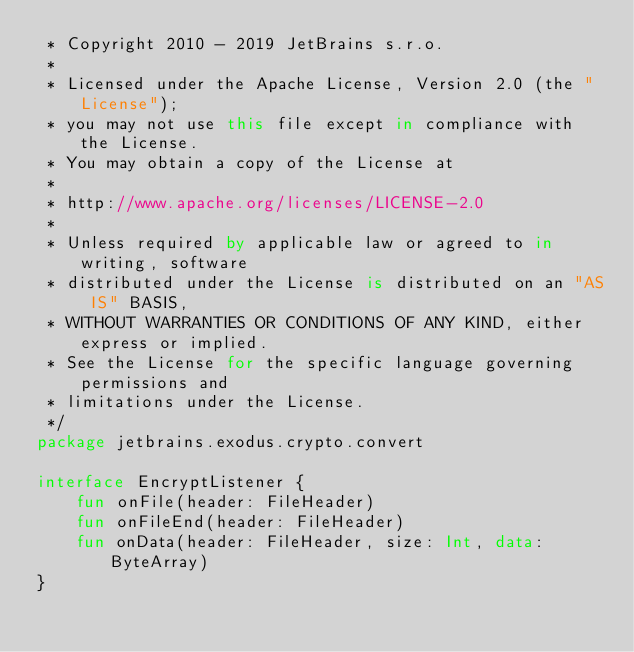<code> <loc_0><loc_0><loc_500><loc_500><_Kotlin_> * Copyright 2010 - 2019 JetBrains s.r.o.
 *
 * Licensed under the Apache License, Version 2.0 (the "License");
 * you may not use this file except in compliance with the License.
 * You may obtain a copy of the License at
 *
 * http://www.apache.org/licenses/LICENSE-2.0
 *
 * Unless required by applicable law or agreed to in writing, software
 * distributed under the License is distributed on an "AS IS" BASIS,
 * WITHOUT WARRANTIES OR CONDITIONS OF ANY KIND, either express or implied.
 * See the License for the specific language governing permissions and
 * limitations under the License.
 */
package jetbrains.exodus.crypto.convert

interface EncryptListener {
    fun onFile(header: FileHeader)
    fun onFileEnd(header: FileHeader)
    fun onData(header: FileHeader, size: Int, data: ByteArray)
}
</code> 